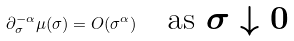Convert formula to latex. <formula><loc_0><loc_0><loc_500><loc_500>\partial ^ { - \alpha } _ { \sigma } \mu ( \sigma ) = O ( \sigma ^ { \alpha } ) \quad \text {as $\sigma\downarrow 0$}</formula> 